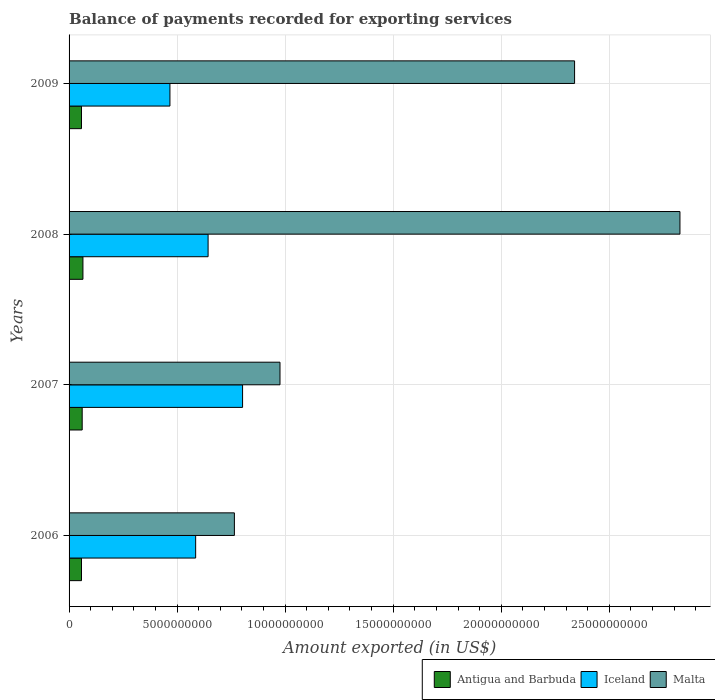How many bars are there on the 4th tick from the bottom?
Provide a succinct answer. 3. What is the amount exported in Malta in 2008?
Your answer should be very brief. 2.83e+1. Across all years, what is the maximum amount exported in Antigua and Barbuda?
Offer a terse response. 6.41e+08. Across all years, what is the minimum amount exported in Iceland?
Provide a short and direct response. 4.67e+09. In which year was the amount exported in Antigua and Barbuda minimum?
Give a very brief answer. 2009. What is the total amount exported in Antigua and Barbuda in the graph?
Your answer should be compact. 2.40e+09. What is the difference between the amount exported in Malta in 2008 and that in 2009?
Provide a short and direct response. 4.88e+09. What is the difference between the amount exported in Antigua and Barbuda in 2009 and the amount exported in Iceland in 2008?
Your response must be concise. -5.86e+09. What is the average amount exported in Iceland per year?
Offer a very short reply. 6.25e+09. In the year 2009, what is the difference between the amount exported in Malta and amount exported in Iceland?
Give a very brief answer. 1.87e+1. What is the ratio of the amount exported in Malta in 2007 to that in 2009?
Offer a terse response. 0.42. What is the difference between the highest and the second highest amount exported in Iceland?
Provide a short and direct response. 1.60e+09. What is the difference between the highest and the lowest amount exported in Antigua and Barbuda?
Give a very brief answer. 6.67e+07. In how many years, is the amount exported in Iceland greater than the average amount exported in Iceland taken over all years?
Provide a short and direct response. 2. Is the sum of the amount exported in Antigua and Barbuda in 2008 and 2009 greater than the maximum amount exported in Malta across all years?
Offer a terse response. No. What does the 3rd bar from the top in 2007 represents?
Keep it short and to the point. Antigua and Barbuda. What does the 2nd bar from the bottom in 2009 represents?
Your response must be concise. Iceland. Is it the case that in every year, the sum of the amount exported in Malta and amount exported in Iceland is greater than the amount exported in Antigua and Barbuda?
Your response must be concise. Yes. How many bars are there?
Offer a terse response. 12. How many years are there in the graph?
Keep it short and to the point. 4. Are the values on the major ticks of X-axis written in scientific E-notation?
Provide a short and direct response. No. Does the graph contain any zero values?
Offer a terse response. No. Where does the legend appear in the graph?
Provide a short and direct response. Bottom right. How many legend labels are there?
Provide a succinct answer. 3. What is the title of the graph?
Offer a terse response. Balance of payments recorded for exporting services. Does "Papua New Guinea" appear as one of the legend labels in the graph?
Ensure brevity in your answer.  No. What is the label or title of the X-axis?
Your answer should be compact. Amount exported (in US$). What is the label or title of the Y-axis?
Offer a terse response. Years. What is the Amount exported (in US$) in Antigua and Barbuda in 2006?
Keep it short and to the point. 5.75e+08. What is the Amount exported (in US$) of Iceland in 2006?
Keep it short and to the point. 5.86e+09. What is the Amount exported (in US$) in Malta in 2006?
Keep it short and to the point. 7.65e+09. What is the Amount exported (in US$) of Antigua and Barbuda in 2007?
Provide a short and direct response. 6.07e+08. What is the Amount exported (in US$) in Iceland in 2007?
Make the answer very short. 8.03e+09. What is the Amount exported (in US$) of Malta in 2007?
Keep it short and to the point. 9.76e+09. What is the Amount exported (in US$) in Antigua and Barbuda in 2008?
Offer a very short reply. 6.41e+08. What is the Amount exported (in US$) of Iceland in 2008?
Ensure brevity in your answer.  6.43e+09. What is the Amount exported (in US$) in Malta in 2008?
Provide a succinct answer. 2.83e+1. What is the Amount exported (in US$) of Antigua and Barbuda in 2009?
Offer a terse response. 5.75e+08. What is the Amount exported (in US$) in Iceland in 2009?
Provide a short and direct response. 4.67e+09. What is the Amount exported (in US$) in Malta in 2009?
Offer a terse response. 2.34e+1. Across all years, what is the maximum Amount exported (in US$) of Antigua and Barbuda?
Your response must be concise. 6.41e+08. Across all years, what is the maximum Amount exported (in US$) in Iceland?
Your answer should be very brief. 8.03e+09. Across all years, what is the maximum Amount exported (in US$) in Malta?
Provide a succinct answer. 2.83e+1. Across all years, what is the minimum Amount exported (in US$) of Antigua and Barbuda?
Your answer should be very brief. 5.75e+08. Across all years, what is the minimum Amount exported (in US$) of Iceland?
Keep it short and to the point. 4.67e+09. Across all years, what is the minimum Amount exported (in US$) of Malta?
Your response must be concise. 7.65e+09. What is the total Amount exported (in US$) in Antigua and Barbuda in the graph?
Your response must be concise. 2.40e+09. What is the total Amount exported (in US$) in Iceland in the graph?
Provide a succinct answer. 2.50e+1. What is the total Amount exported (in US$) in Malta in the graph?
Ensure brevity in your answer.  6.91e+1. What is the difference between the Amount exported (in US$) in Antigua and Barbuda in 2006 and that in 2007?
Your answer should be compact. -3.22e+07. What is the difference between the Amount exported (in US$) of Iceland in 2006 and that in 2007?
Make the answer very short. -2.17e+09. What is the difference between the Amount exported (in US$) in Malta in 2006 and that in 2007?
Ensure brevity in your answer.  -2.11e+09. What is the difference between the Amount exported (in US$) of Antigua and Barbuda in 2006 and that in 2008?
Your response must be concise. -6.66e+07. What is the difference between the Amount exported (in US$) of Iceland in 2006 and that in 2008?
Offer a terse response. -5.76e+08. What is the difference between the Amount exported (in US$) in Malta in 2006 and that in 2008?
Your answer should be very brief. -2.06e+1. What is the difference between the Amount exported (in US$) in Antigua and Barbuda in 2006 and that in 2009?
Offer a terse response. 1.48e+05. What is the difference between the Amount exported (in US$) of Iceland in 2006 and that in 2009?
Offer a very short reply. 1.19e+09. What is the difference between the Amount exported (in US$) in Malta in 2006 and that in 2009?
Provide a succinct answer. -1.57e+1. What is the difference between the Amount exported (in US$) of Antigua and Barbuda in 2007 and that in 2008?
Provide a short and direct response. -3.44e+07. What is the difference between the Amount exported (in US$) in Iceland in 2007 and that in 2008?
Ensure brevity in your answer.  1.60e+09. What is the difference between the Amount exported (in US$) in Malta in 2007 and that in 2008?
Keep it short and to the point. -1.85e+1. What is the difference between the Amount exported (in US$) of Antigua and Barbuda in 2007 and that in 2009?
Your answer should be very brief. 3.23e+07. What is the difference between the Amount exported (in US$) in Iceland in 2007 and that in 2009?
Keep it short and to the point. 3.36e+09. What is the difference between the Amount exported (in US$) in Malta in 2007 and that in 2009?
Ensure brevity in your answer.  -1.36e+1. What is the difference between the Amount exported (in US$) of Antigua and Barbuda in 2008 and that in 2009?
Your response must be concise. 6.67e+07. What is the difference between the Amount exported (in US$) in Iceland in 2008 and that in 2009?
Your answer should be compact. 1.77e+09. What is the difference between the Amount exported (in US$) of Malta in 2008 and that in 2009?
Ensure brevity in your answer.  4.88e+09. What is the difference between the Amount exported (in US$) of Antigua and Barbuda in 2006 and the Amount exported (in US$) of Iceland in 2007?
Your answer should be compact. -7.45e+09. What is the difference between the Amount exported (in US$) of Antigua and Barbuda in 2006 and the Amount exported (in US$) of Malta in 2007?
Provide a short and direct response. -9.19e+09. What is the difference between the Amount exported (in US$) in Iceland in 2006 and the Amount exported (in US$) in Malta in 2007?
Your answer should be very brief. -3.90e+09. What is the difference between the Amount exported (in US$) in Antigua and Barbuda in 2006 and the Amount exported (in US$) in Iceland in 2008?
Your answer should be very brief. -5.86e+09. What is the difference between the Amount exported (in US$) of Antigua and Barbuda in 2006 and the Amount exported (in US$) of Malta in 2008?
Give a very brief answer. -2.77e+1. What is the difference between the Amount exported (in US$) of Iceland in 2006 and the Amount exported (in US$) of Malta in 2008?
Make the answer very short. -2.24e+1. What is the difference between the Amount exported (in US$) in Antigua and Barbuda in 2006 and the Amount exported (in US$) in Iceland in 2009?
Your answer should be compact. -4.09e+09. What is the difference between the Amount exported (in US$) in Antigua and Barbuda in 2006 and the Amount exported (in US$) in Malta in 2009?
Ensure brevity in your answer.  -2.28e+1. What is the difference between the Amount exported (in US$) of Iceland in 2006 and the Amount exported (in US$) of Malta in 2009?
Provide a short and direct response. -1.75e+1. What is the difference between the Amount exported (in US$) of Antigua and Barbuda in 2007 and the Amount exported (in US$) of Iceland in 2008?
Give a very brief answer. -5.83e+09. What is the difference between the Amount exported (in US$) in Antigua and Barbuda in 2007 and the Amount exported (in US$) in Malta in 2008?
Offer a very short reply. -2.77e+1. What is the difference between the Amount exported (in US$) of Iceland in 2007 and the Amount exported (in US$) of Malta in 2008?
Keep it short and to the point. -2.02e+1. What is the difference between the Amount exported (in US$) in Antigua and Barbuda in 2007 and the Amount exported (in US$) in Iceland in 2009?
Give a very brief answer. -4.06e+09. What is the difference between the Amount exported (in US$) of Antigua and Barbuda in 2007 and the Amount exported (in US$) of Malta in 2009?
Offer a terse response. -2.28e+1. What is the difference between the Amount exported (in US$) of Iceland in 2007 and the Amount exported (in US$) of Malta in 2009?
Make the answer very short. -1.54e+1. What is the difference between the Amount exported (in US$) of Antigua and Barbuda in 2008 and the Amount exported (in US$) of Iceland in 2009?
Ensure brevity in your answer.  -4.03e+09. What is the difference between the Amount exported (in US$) in Antigua and Barbuda in 2008 and the Amount exported (in US$) in Malta in 2009?
Offer a very short reply. -2.28e+1. What is the difference between the Amount exported (in US$) in Iceland in 2008 and the Amount exported (in US$) in Malta in 2009?
Make the answer very short. -1.70e+1. What is the average Amount exported (in US$) in Antigua and Barbuda per year?
Your answer should be very brief. 6.00e+08. What is the average Amount exported (in US$) in Iceland per year?
Offer a very short reply. 6.25e+09. What is the average Amount exported (in US$) of Malta per year?
Give a very brief answer. 1.73e+1. In the year 2006, what is the difference between the Amount exported (in US$) of Antigua and Barbuda and Amount exported (in US$) of Iceland?
Your answer should be compact. -5.28e+09. In the year 2006, what is the difference between the Amount exported (in US$) of Antigua and Barbuda and Amount exported (in US$) of Malta?
Your answer should be very brief. -7.08e+09. In the year 2006, what is the difference between the Amount exported (in US$) of Iceland and Amount exported (in US$) of Malta?
Offer a very short reply. -1.79e+09. In the year 2007, what is the difference between the Amount exported (in US$) of Antigua and Barbuda and Amount exported (in US$) of Iceland?
Your answer should be compact. -7.42e+09. In the year 2007, what is the difference between the Amount exported (in US$) in Antigua and Barbuda and Amount exported (in US$) in Malta?
Your response must be concise. -9.15e+09. In the year 2007, what is the difference between the Amount exported (in US$) of Iceland and Amount exported (in US$) of Malta?
Ensure brevity in your answer.  -1.73e+09. In the year 2008, what is the difference between the Amount exported (in US$) of Antigua and Barbuda and Amount exported (in US$) of Iceland?
Make the answer very short. -5.79e+09. In the year 2008, what is the difference between the Amount exported (in US$) of Antigua and Barbuda and Amount exported (in US$) of Malta?
Give a very brief answer. -2.76e+1. In the year 2008, what is the difference between the Amount exported (in US$) of Iceland and Amount exported (in US$) of Malta?
Offer a terse response. -2.18e+1. In the year 2009, what is the difference between the Amount exported (in US$) of Antigua and Barbuda and Amount exported (in US$) of Iceland?
Ensure brevity in your answer.  -4.09e+09. In the year 2009, what is the difference between the Amount exported (in US$) in Antigua and Barbuda and Amount exported (in US$) in Malta?
Give a very brief answer. -2.28e+1. In the year 2009, what is the difference between the Amount exported (in US$) in Iceland and Amount exported (in US$) in Malta?
Your answer should be very brief. -1.87e+1. What is the ratio of the Amount exported (in US$) in Antigua and Barbuda in 2006 to that in 2007?
Provide a succinct answer. 0.95. What is the ratio of the Amount exported (in US$) of Iceland in 2006 to that in 2007?
Make the answer very short. 0.73. What is the ratio of the Amount exported (in US$) of Malta in 2006 to that in 2007?
Your response must be concise. 0.78. What is the ratio of the Amount exported (in US$) in Antigua and Barbuda in 2006 to that in 2008?
Your answer should be compact. 0.9. What is the ratio of the Amount exported (in US$) in Iceland in 2006 to that in 2008?
Your answer should be compact. 0.91. What is the ratio of the Amount exported (in US$) in Malta in 2006 to that in 2008?
Your response must be concise. 0.27. What is the ratio of the Amount exported (in US$) in Antigua and Barbuda in 2006 to that in 2009?
Provide a succinct answer. 1. What is the ratio of the Amount exported (in US$) of Iceland in 2006 to that in 2009?
Offer a very short reply. 1.25. What is the ratio of the Amount exported (in US$) in Malta in 2006 to that in 2009?
Ensure brevity in your answer.  0.33. What is the ratio of the Amount exported (in US$) of Antigua and Barbuda in 2007 to that in 2008?
Offer a very short reply. 0.95. What is the ratio of the Amount exported (in US$) in Iceland in 2007 to that in 2008?
Keep it short and to the point. 1.25. What is the ratio of the Amount exported (in US$) in Malta in 2007 to that in 2008?
Your answer should be very brief. 0.35. What is the ratio of the Amount exported (in US$) in Antigua and Barbuda in 2007 to that in 2009?
Give a very brief answer. 1.06. What is the ratio of the Amount exported (in US$) in Iceland in 2007 to that in 2009?
Make the answer very short. 1.72. What is the ratio of the Amount exported (in US$) of Malta in 2007 to that in 2009?
Give a very brief answer. 0.42. What is the ratio of the Amount exported (in US$) of Antigua and Barbuda in 2008 to that in 2009?
Keep it short and to the point. 1.12. What is the ratio of the Amount exported (in US$) in Iceland in 2008 to that in 2009?
Your answer should be compact. 1.38. What is the ratio of the Amount exported (in US$) of Malta in 2008 to that in 2009?
Offer a terse response. 1.21. What is the difference between the highest and the second highest Amount exported (in US$) of Antigua and Barbuda?
Make the answer very short. 3.44e+07. What is the difference between the highest and the second highest Amount exported (in US$) in Iceland?
Give a very brief answer. 1.60e+09. What is the difference between the highest and the second highest Amount exported (in US$) of Malta?
Provide a succinct answer. 4.88e+09. What is the difference between the highest and the lowest Amount exported (in US$) of Antigua and Barbuda?
Offer a terse response. 6.67e+07. What is the difference between the highest and the lowest Amount exported (in US$) of Iceland?
Provide a succinct answer. 3.36e+09. What is the difference between the highest and the lowest Amount exported (in US$) of Malta?
Make the answer very short. 2.06e+1. 